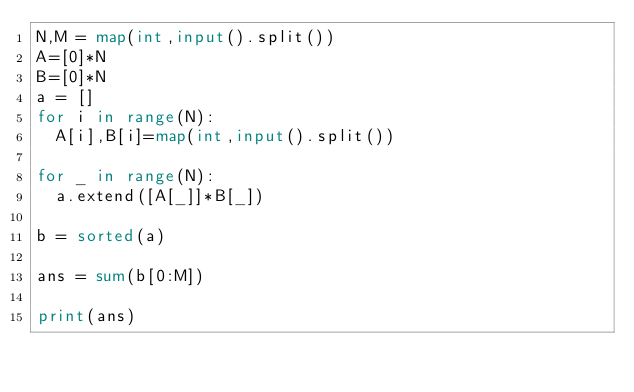<code> <loc_0><loc_0><loc_500><loc_500><_Python_>N,M = map(int,input().split())
A=[0]*N
B=[0]*N
a = []
for i in range(N):
  A[i],B[i]=map(int,input().split())
  
for _ in range(N):
  a.extend([A[_]]*B[_])
  
b = sorted(a)

ans = sum(b[0:M])

print(ans)


</code> 